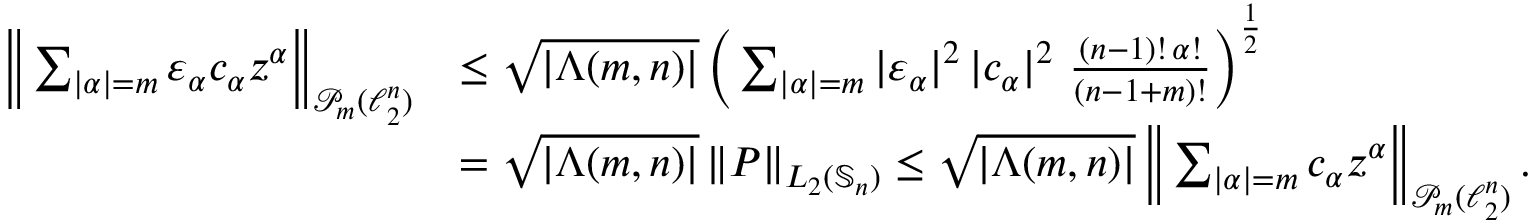Convert formula to latex. <formula><loc_0><loc_0><loc_500><loc_500>\begin{array} { r l } { \left \| \sum _ { | \alpha | = m } \varepsilon _ { \alpha } c _ { \alpha } z ^ { \alpha } \right \| _ { \mathcal { P } _ { m } ( \ell _ { 2 } ^ { n } ) } } & { \leq \sqrt { | \Lambda ( m , n ) | } \, \left ( \sum _ { | \alpha | = m } | \varepsilon _ { \alpha } | ^ { 2 } \, | c _ { \alpha } | ^ { 2 } \, \frac { ( n - 1 ) ! \, \alpha ! } { ( n - 1 + m ) ! } \right ) ^ { \frac { 1 } { 2 } } } \\ & { = \sqrt { | \Lambda ( m , n ) | } \, \| P \| _ { L _ { 2 } ( \mathbb { S } _ { n } ) } \leq \sqrt { | \Lambda ( m , n ) | } \, \left \| \sum _ { | \alpha | = m } c _ { \alpha } z ^ { \alpha } \right \| _ { \mathcal { P } _ { m } ( \ell _ { 2 } ^ { n } ) } \, . } \end{array}</formula> 